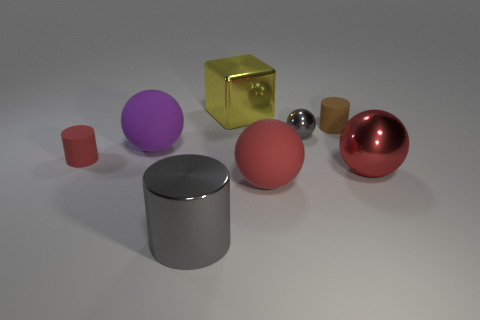Subtract 1 spheres. How many spheres are left? 3 Subtract all green spheres. Subtract all green cylinders. How many spheres are left? 4 Add 1 big green matte balls. How many objects exist? 9 Subtract all cylinders. How many objects are left? 5 Add 8 large metallic cubes. How many large metallic cubes exist? 9 Subtract 1 gray balls. How many objects are left? 7 Subtract all red things. Subtract all tiny red rubber cylinders. How many objects are left? 4 Add 1 yellow metallic objects. How many yellow metallic objects are left? 2 